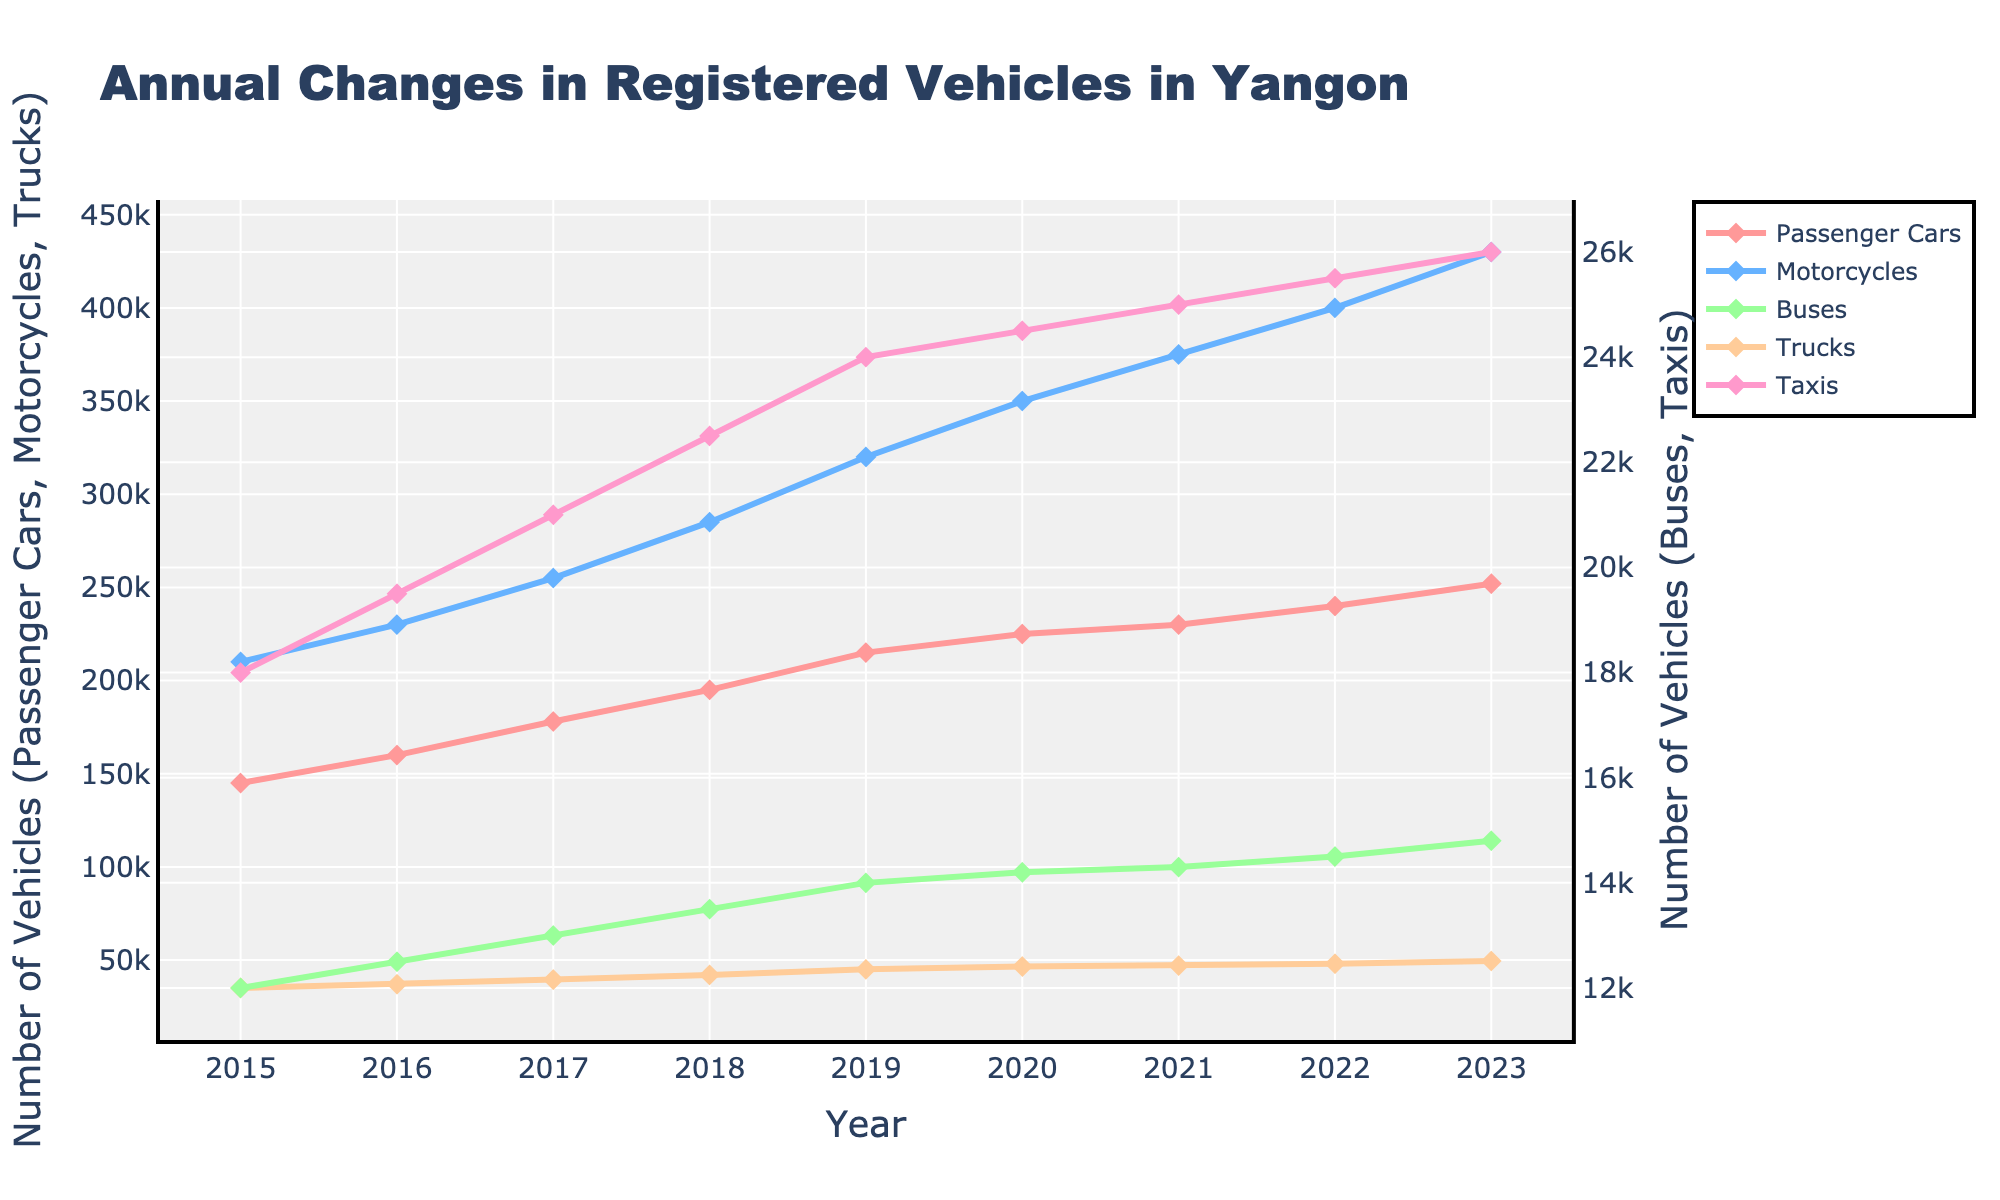Which vehicle type shows the highest increase in number from 2015 to 2023? To determine which vehicle type has the highest increase, subtract the number in 2015 from the number in 2023 for each type. Passenger Cars: 252,000 - 145,000 = 107,000; Motorcycles: 430,000 - 210,000 = 220,000; Buses: 14,800 - 12,000 = 2,800; Trucks: 49,500 - 35,000 = 14,500; Taxis: 26,000 - 18,000 = 8,000. Motorcycles show the highest increase.
Answer: Motorcycles How many more motorcycles were registered than passenger cars in 2023? To find the difference in the number of motorcycles and passenger cars in 2023, subtract the number of passenger cars from the number of motorcycles: 430,000 - 252,000 = 178,000.
Answer: 178,000 Is the rate of increase for buses steady over the years 2015 to 2023? Examine the trend line for the buses. The increases are: 12,500 - 12,000 = 500 (2016), 13,000 - 12,500 = 500 (2017), 13,500 - 13,000 = 500 (2018), 14,000 - 13,500 = 500 (2019), 14,200 - 14,000 = 200 (2020), 14,300 - 14,200 = 100 (2021), 14,500 - 14,300 = 200 (2022), 14,800 - 14,500 = 300 (2023). The rates are relatively consistent with small variations.
Answer: Mostly steady with minor variations In which year did the number of registered trucks reach 42,000? Track the 'Trucks' line to find where it reaches 42,000. From the data, trucks reached 42,000 in 2018.
Answer: 2018 What's the average number of passenger cars from 2015 to 2023? Sum the number of passenger cars for all years and divide by the number of years. (145,000 + 160,000 + 178,000 + 195,000 + 215,000 + 225,000 + 230,000 + 240,000 + 252,000) / 9 = 1,840,000 / 9 ≈ 204,444
Answer: 204,444 Compare the number of registered taxis and buses in 2023. Which has more? Look at the values for 2023: Taxis = 26,000; Buses = 14,800. Since 26,000 > 14,800, taxis have more registered vehicles.
Answer: Taxis What is the total number of registered vehicles for all types in 2020? Sum the number of each type in 2020: Passenger Cars = 225,000; Motorcycles = 350,000; Buses = 14,200; Trucks = 46,500; Taxis = 24,500. Total = 225,000 + 350,000 + 14,200 + 46,500 + 24,500 = 660,200
Answer: 660,200 Which color line represents motorcycles in the graph? The color used for motorcycles is described in the code as '#66B2FF', which is a shade of blue. Therefore, the blue line represents motorcycles.
Answer: Blue 